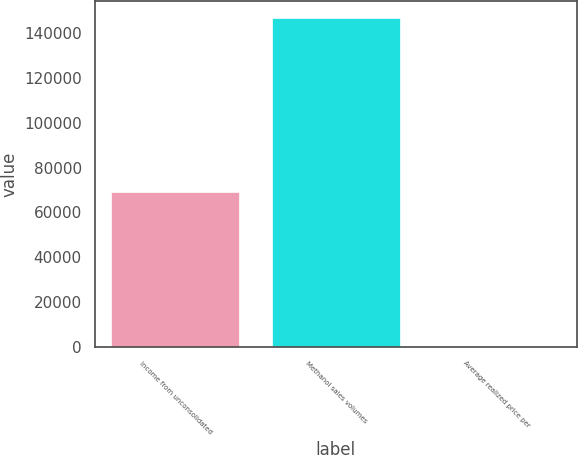Convert chart to OTSL. <chart><loc_0><loc_0><loc_500><loc_500><bar_chart><fcel>Income from unconsolidated<fcel>Methanol sales volumes<fcel>Average realized price per<nl><fcel>69100<fcel>146821<fcel>0.69<nl></chart> 